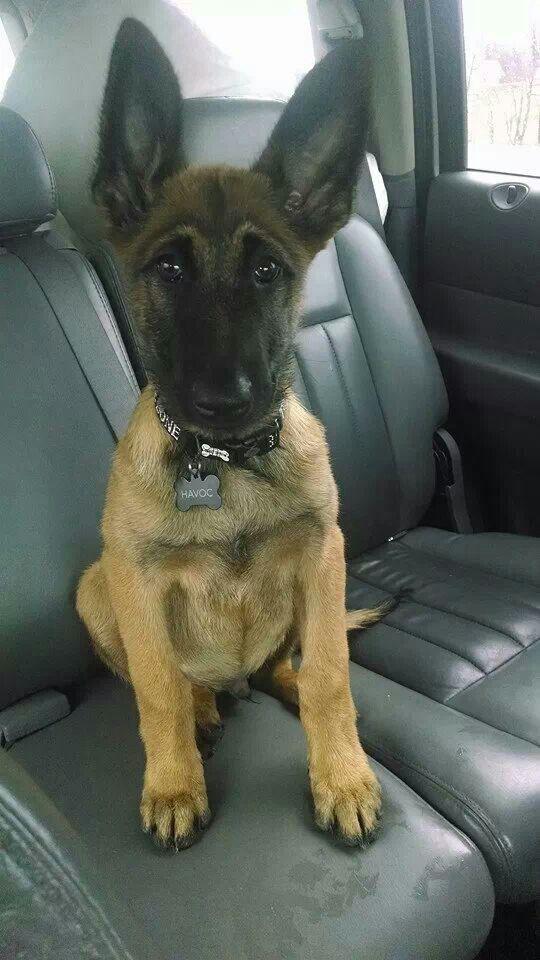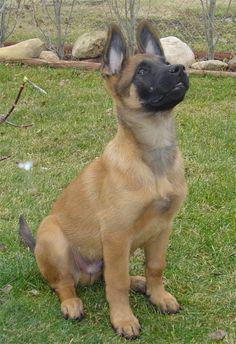The first image is the image on the left, the second image is the image on the right. Evaluate the accuracy of this statement regarding the images: "One dog is looking up.". Is it true? Answer yes or no. Yes. The first image is the image on the left, the second image is the image on the right. Assess this claim about the two images: "In at least one image the dog is not looking toward the camera.". Correct or not? Answer yes or no. Yes. 